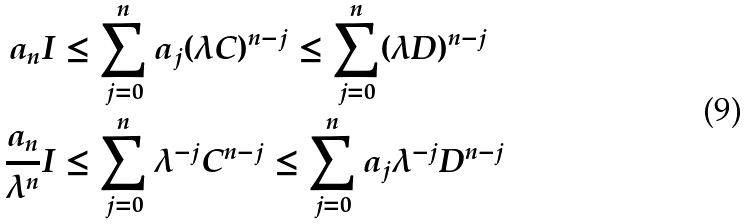<formula> <loc_0><loc_0><loc_500><loc_500>a _ { n } I & \leq \sum _ { j = 0 } ^ { n } a _ { j } ( \lambda C ) ^ { n - j } \leq \sum _ { j = 0 } ^ { n } ( \lambda D ) ^ { n - j } \\ \frac { a _ { n } } { \lambda ^ { n } } I & \leq \sum _ { j = 0 } ^ { n } \lambda ^ { - j } C ^ { n - j } \leq \sum _ { j = 0 } ^ { n } a _ { j } \lambda ^ { - j } D ^ { n - j }</formula> 